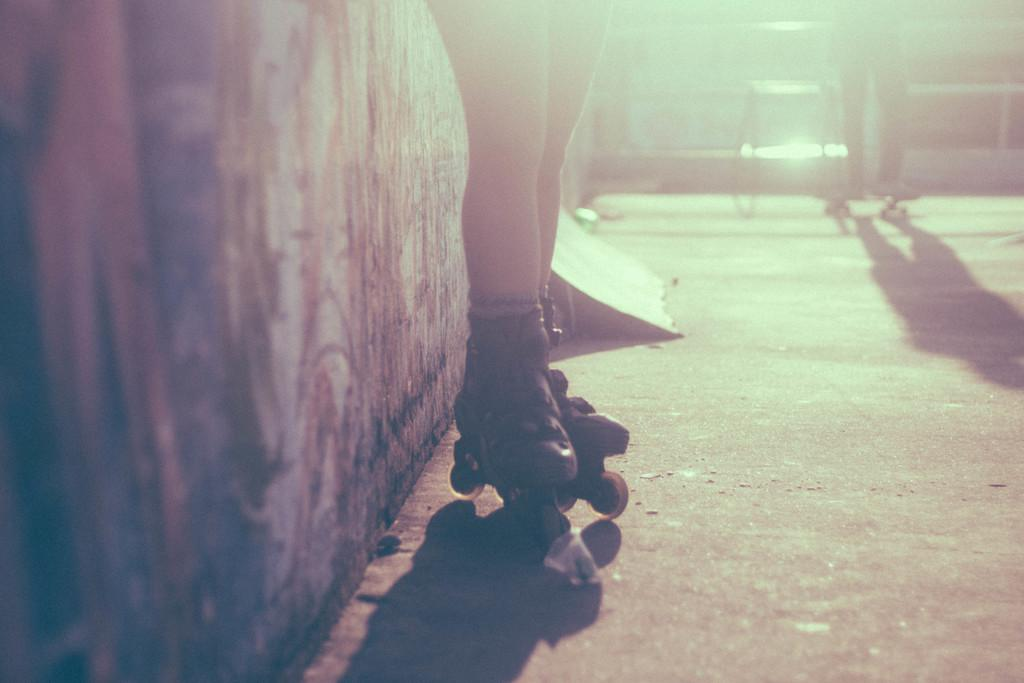What activity is taking place in the image? There is a skating area in the image, and two persons are skating. What can be seen on the left side of the image? There is a wall on the left side of the image. What type of reaction can be seen from the potato in the image? There is no potato present in the image, so it is not possible to determine any reaction. 